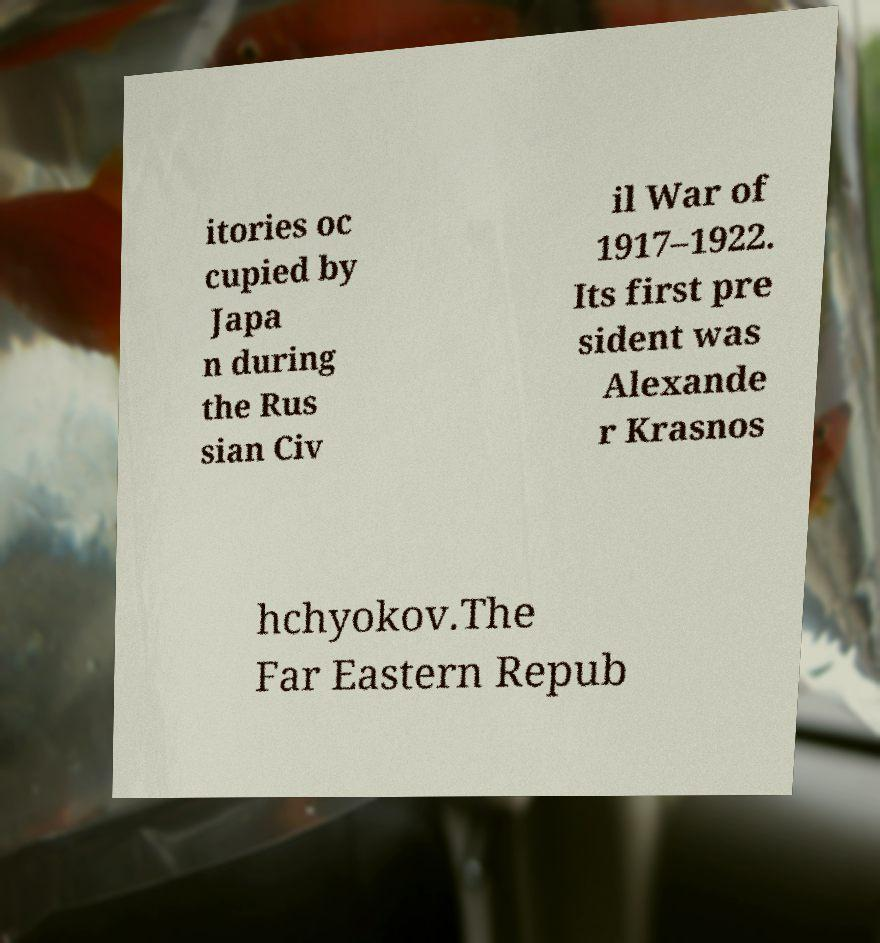Could you assist in decoding the text presented in this image and type it out clearly? itories oc cupied by Japa n during the Rus sian Civ il War of 1917–1922. Its first pre sident was Alexande r Krasnos hchyokov.The Far Eastern Repub 